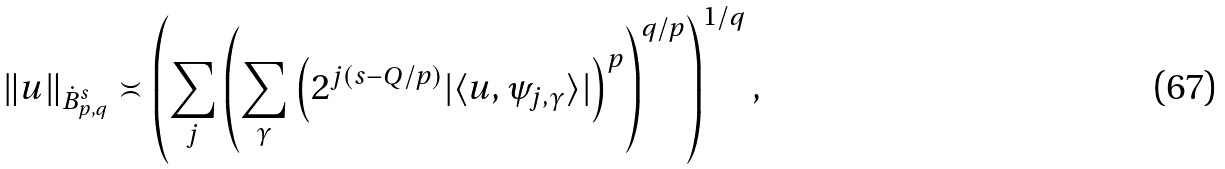<formula> <loc_0><loc_0><loc_500><loc_500>\| u \| _ { { \dot { B } } _ { p , q } ^ { s } } \asymp \left ( \sum _ { j } \left ( \sum _ { \gamma } \left ( 2 ^ { j ( s - Q / p ) } | \langle u , \psi _ { j , \gamma } \rangle | \right ) ^ { p } \right ) ^ { q / p } \right ) ^ { 1 / q } ,</formula> 